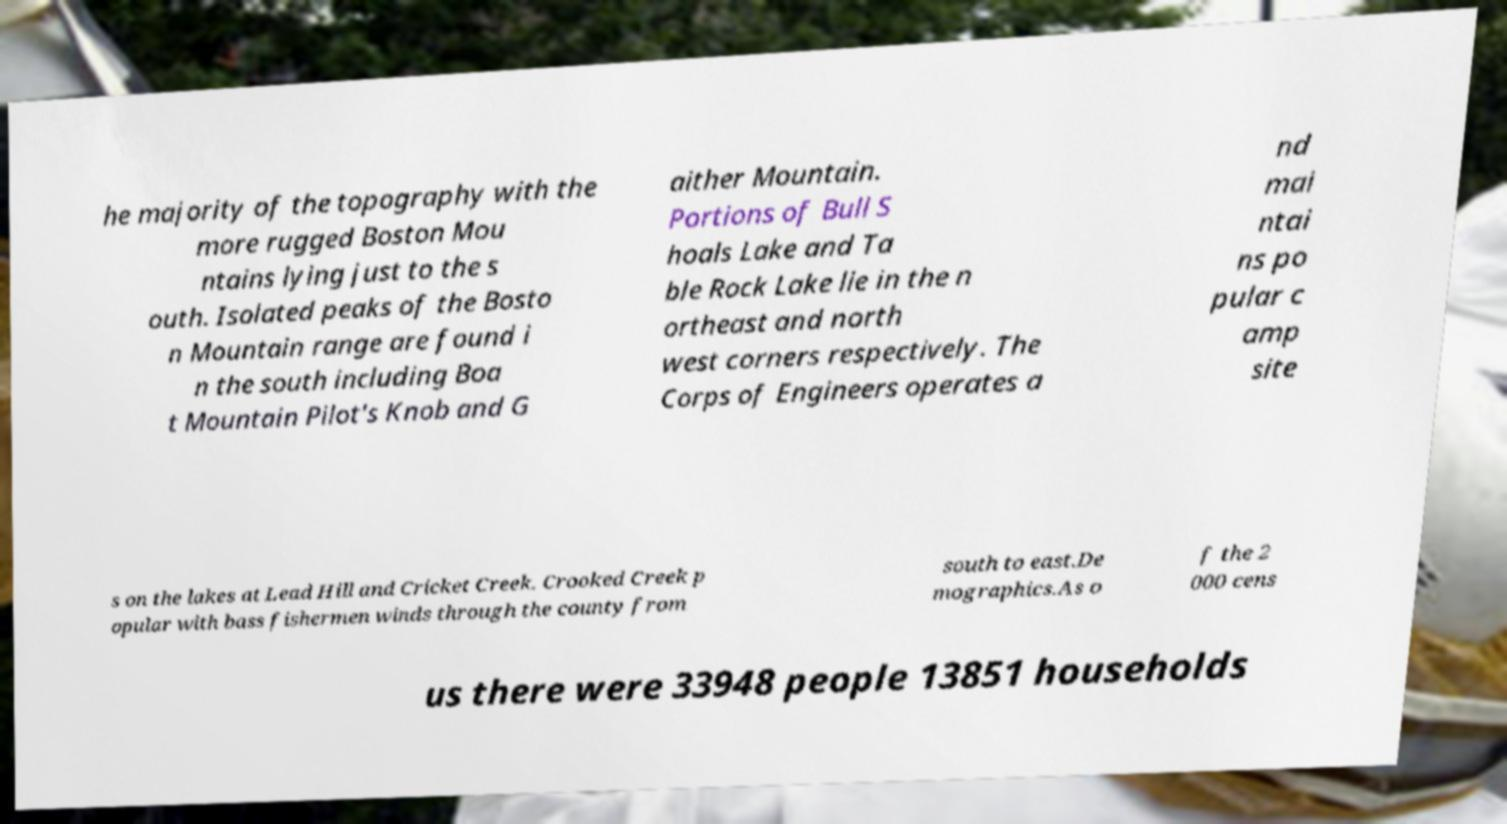For documentation purposes, I need the text within this image transcribed. Could you provide that? he majority of the topography with the more rugged Boston Mou ntains lying just to the s outh. Isolated peaks of the Bosto n Mountain range are found i n the south including Boa t Mountain Pilot's Knob and G aither Mountain. Portions of Bull S hoals Lake and Ta ble Rock Lake lie in the n ortheast and north west corners respectively. The Corps of Engineers operates a nd mai ntai ns po pular c amp site s on the lakes at Lead Hill and Cricket Creek. Crooked Creek p opular with bass fishermen winds through the county from south to east.De mographics.As o f the 2 000 cens us there were 33948 people 13851 households 